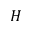Convert formula to latex. <formula><loc_0><loc_0><loc_500><loc_500>H</formula> 